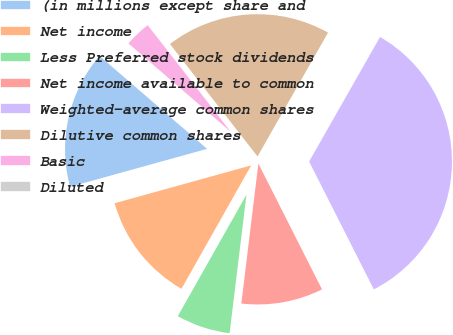<chart> <loc_0><loc_0><loc_500><loc_500><pie_chart><fcel>(in millions except share and<fcel>Net income<fcel>Less Preferred stock dividends<fcel>Net income available to common<fcel>Weighted-average common shares<fcel>Dilutive common shares<fcel>Basic<fcel>Diluted<nl><fcel>15.64%<fcel>12.51%<fcel>6.26%<fcel>9.38%<fcel>34.31%<fcel>18.77%<fcel>3.13%<fcel>0.0%<nl></chart> 